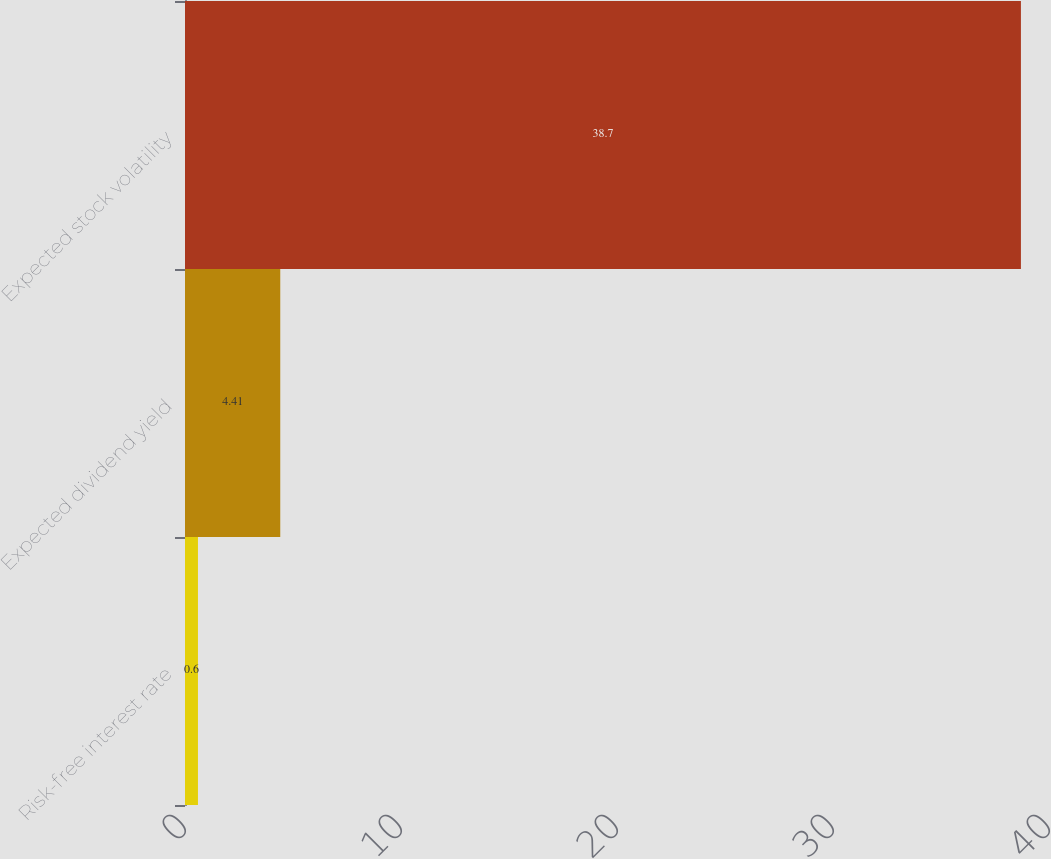Convert chart. <chart><loc_0><loc_0><loc_500><loc_500><bar_chart><fcel>Risk-free interest rate<fcel>Expected dividend yield<fcel>Expected stock volatility<nl><fcel>0.6<fcel>4.41<fcel>38.7<nl></chart> 